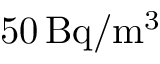<formula> <loc_0><loc_0><loc_500><loc_500>5 0 \, B q / m ^ { 3 }</formula> 